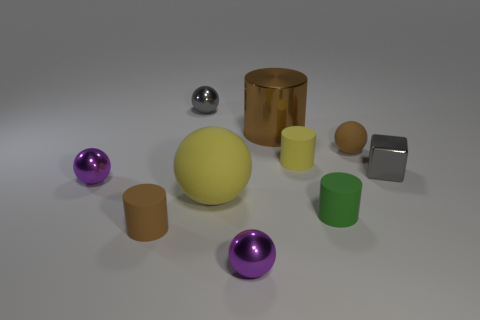Subtract all yellow cylinders. How many cylinders are left? 3 Subtract all cubes. How many objects are left? 9 Subtract 4 cylinders. How many cylinders are left? 0 Subtract all brown cylinders. How many cylinders are left? 2 Subtract all red cylinders. How many brown balls are left? 1 Subtract all big brown objects. Subtract all tiny brown things. How many objects are left? 7 Add 3 yellow rubber cylinders. How many yellow rubber cylinders are left? 4 Add 6 green metal things. How many green metal things exist? 6 Subtract 2 brown cylinders. How many objects are left? 8 Subtract all green cylinders. Subtract all gray balls. How many cylinders are left? 3 